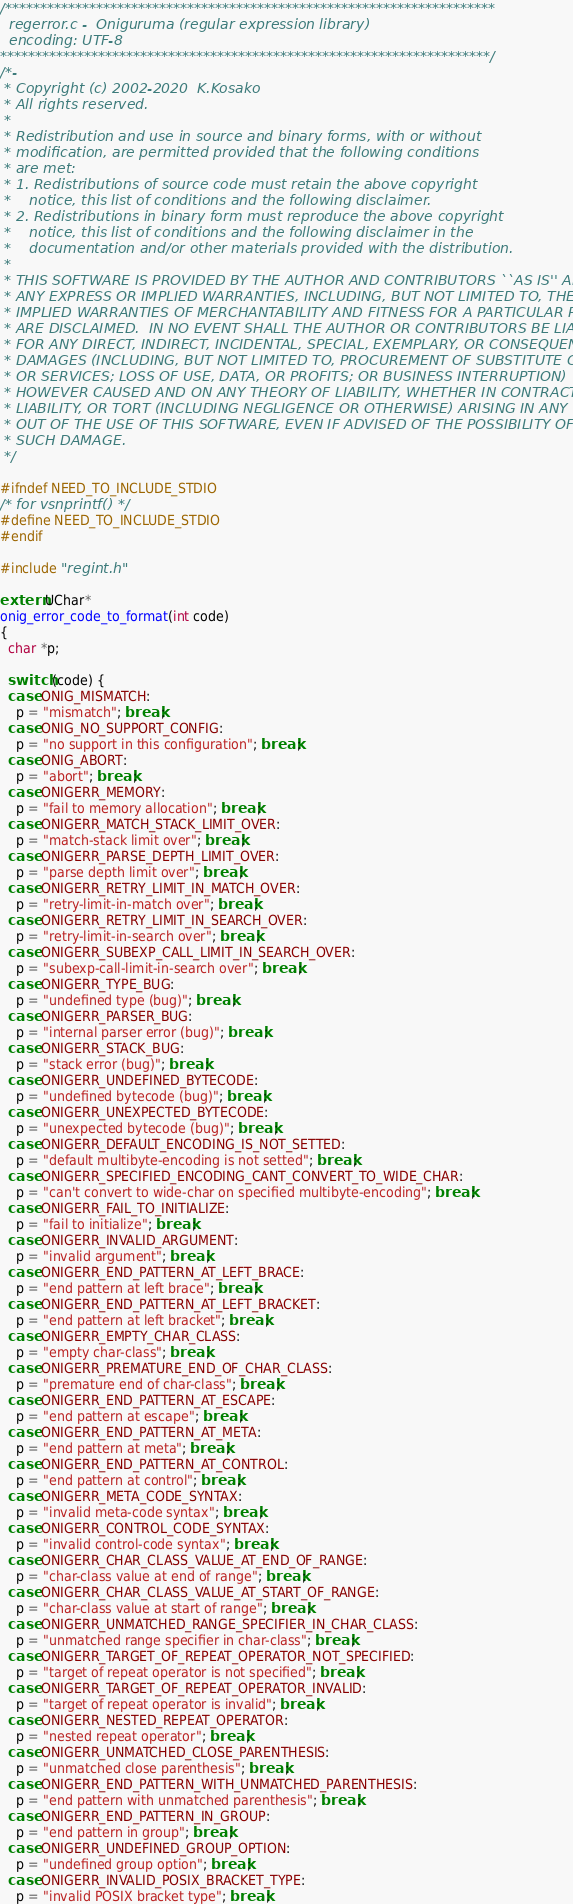<code> <loc_0><loc_0><loc_500><loc_500><_C_>/**********************************************************************
  regerror.c -  Oniguruma (regular expression library)
  encoding: UTF-8
**********************************************************************/
/*-
 * Copyright (c) 2002-2020  K.Kosako
 * All rights reserved.
 *
 * Redistribution and use in source and binary forms, with or without
 * modification, are permitted provided that the following conditions
 * are met:
 * 1. Redistributions of source code must retain the above copyright
 *    notice, this list of conditions and the following disclaimer.
 * 2. Redistributions in binary form must reproduce the above copyright
 *    notice, this list of conditions and the following disclaimer in the
 *    documentation and/or other materials provided with the distribution.
 *
 * THIS SOFTWARE IS PROVIDED BY THE AUTHOR AND CONTRIBUTORS ``AS IS'' AND
 * ANY EXPRESS OR IMPLIED WARRANTIES, INCLUDING, BUT NOT LIMITED TO, THE
 * IMPLIED WARRANTIES OF MERCHANTABILITY AND FITNESS FOR A PARTICULAR PURPOSE
 * ARE DISCLAIMED.  IN NO EVENT SHALL THE AUTHOR OR CONTRIBUTORS BE LIABLE
 * FOR ANY DIRECT, INDIRECT, INCIDENTAL, SPECIAL, EXEMPLARY, OR CONSEQUENTIAL
 * DAMAGES (INCLUDING, BUT NOT LIMITED TO, PROCUREMENT OF SUBSTITUTE GOODS
 * OR SERVICES; LOSS OF USE, DATA, OR PROFITS; OR BUSINESS INTERRUPTION)
 * HOWEVER CAUSED AND ON ANY THEORY OF LIABILITY, WHETHER IN CONTRACT, STRICT
 * LIABILITY, OR TORT (INCLUDING NEGLIGENCE OR OTHERWISE) ARISING IN ANY WAY
 * OUT OF THE USE OF THIS SOFTWARE, EVEN IF ADVISED OF THE POSSIBILITY OF
 * SUCH DAMAGE.
 */

#ifndef NEED_TO_INCLUDE_STDIO
/* for vsnprintf() */
#define NEED_TO_INCLUDE_STDIO
#endif

#include "regint.h"

extern UChar*
onig_error_code_to_format(int code)
{
  char *p;

  switch (code) {
  case ONIG_MISMATCH:
    p = "mismatch"; break;
  case ONIG_NO_SUPPORT_CONFIG:
    p = "no support in this configuration"; break;
  case ONIG_ABORT:
    p = "abort"; break;
  case ONIGERR_MEMORY:
    p = "fail to memory allocation"; break;
  case ONIGERR_MATCH_STACK_LIMIT_OVER:
    p = "match-stack limit over"; break;
  case ONIGERR_PARSE_DEPTH_LIMIT_OVER:
    p = "parse depth limit over"; break;
  case ONIGERR_RETRY_LIMIT_IN_MATCH_OVER:
    p = "retry-limit-in-match over"; break;
  case ONIGERR_RETRY_LIMIT_IN_SEARCH_OVER:
    p = "retry-limit-in-search over"; break;
  case ONIGERR_SUBEXP_CALL_LIMIT_IN_SEARCH_OVER:
    p = "subexp-call-limit-in-search over"; break;
  case ONIGERR_TYPE_BUG:
    p = "undefined type (bug)"; break;
  case ONIGERR_PARSER_BUG:
    p = "internal parser error (bug)"; break;
  case ONIGERR_STACK_BUG:
    p = "stack error (bug)"; break;
  case ONIGERR_UNDEFINED_BYTECODE:
    p = "undefined bytecode (bug)"; break;
  case ONIGERR_UNEXPECTED_BYTECODE:
    p = "unexpected bytecode (bug)"; break;
  case ONIGERR_DEFAULT_ENCODING_IS_NOT_SETTED:
    p = "default multibyte-encoding is not setted"; break;
  case ONIGERR_SPECIFIED_ENCODING_CANT_CONVERT_TO_WIDE_CHAR:
    p = "can't convert to wide-char on specified multibyte-encoding"; break;
  case ONIGERR_FAIL_TO_INITIALIZE:
    p = "fail to initialize"; break;
  case ONIGERR_INVALID_ARGUMENT:
    p = "invalid argument"; break;
  case ONIGERR_END_PATTERN_AT_LEFT_BRACE:
    p = "end pattern at left brace"; break;
  case ONIGERR_END_PATTERN_AT_LEFT_BRACKET:
    p = "end pattern at left bracket"; break;
  case ONIGERR_EMPTY_CHAR_CLASS:
    p = "empty char-class"; break;
  case ONIGERR_PREMATURE_END_OF_CHAR_CLASS:
    p = "premature end of char-class"; break;
  case ONIGERR_END_PATTERN_AT_ESCAPE:
    p = "end pattern at escape"; break;
  case ONIGERR_END_PATTERN_AT_META:
    p = "end pattern at meta"; break;
  case ONIGERR_END_PATTERN_AT_CONTROL:
    p = "end pattern at control"; break;
  case ONIGERR_META_CODE_SYNTAX:
    p = "invalid meta-code syntax"; break;
  case ONIGERR_CONTROL_CODE_SYNTAX:
    p = "invalid control-code syntax"; break;
  case ONIGERR_CHAR_CLASS_VALUE_AT_END_OF_RANGE:
    p = "char-class value at end of range"; break;
  case ONIGERR_CHAR_CLASS_VALUE_AT_START_OF_RANGE:
    p = "char-class value at start of range"; break;
  case ONIGERR_UNMATCHED_RANGE_SPECIFIER_IN_CHAR_CLASS:
    p = "unmatched range specifier in char-class"; break;
  case ONIGERR_TARGET_OF_REPEAT_OPERATOR_NOT_SPECIFIED:
    p = "target of repeat operator is not specified"; break;
  case ONIGERR_TARGET_OF_REPEAT_OPERATOR_INVALID:
    p = "target of repeat operator is invalid"; break;
  case ONIGERR_NESTED_REPEAT_OPERATOR:
    p = "nested repeat operator"; break;
  case ONIGERR_UNMATCHED_CLOSE_PARENTHESIS:
    p = "unmatched close parenthesis"; break;
  case ONIGERR_END_PATTERN_WITH_UNMATCHED_PARENTHESIS:
    p = "end pattern with unmatched parenthesis"; break;
  case ONIGERR_END_PATTERN_IN_GROUP:
    p = "end pattern in group"; break;
  case ONIGERR_UNDEFINED_GROUP_OPTION:
    p = "undefined group option"; break;
  case ONIGERR_INVALID_POSIX_BRACKET_TYPE:
    p = "invalid POSIX bracket type"; break;</code> 